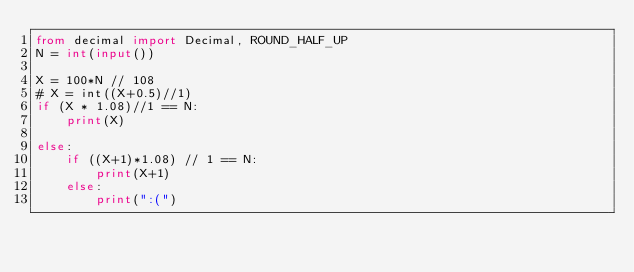<code> <loc_0><loc_0><loc_500><loc_500><_Python_>from decimal import Decimal, ROUND_HALF_UP
N = int(input())

X = 100*N // 108
# X = int((X+0.5)//1)
if (X * 1.08)//1 == N:
    print(X)

else:
    if ((X+1)*1.08) // 1 == N:
        print(X+1)
    else:
        print(":(")
</code> 